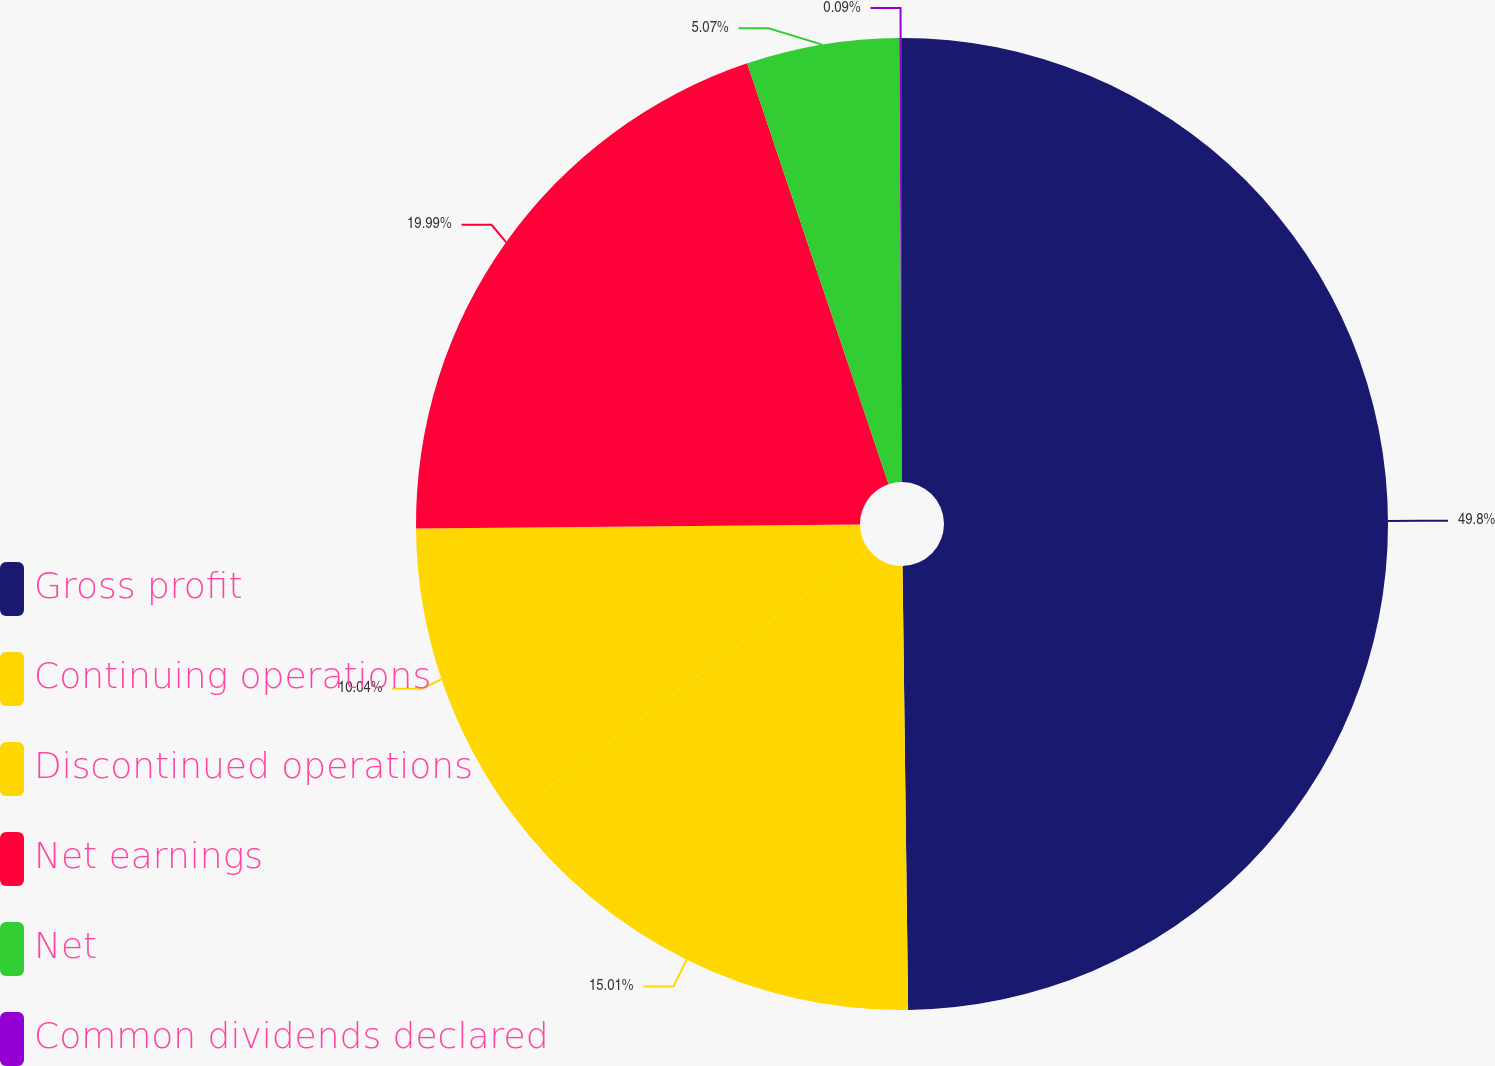<chart> <loc_0><loc_0><loc_500><loc_500><pie_chart><fcel>Gross profit<fcel>Continuing operations<fcel>Discontinued operations<fcel>Net earnings<fcel>Net<fcel>Common dividends declared<nl><fcel>49.8%<fcel>15.01%<fcel>10.04%<fcel>19.99%<fcel>5.07%<fcel>0.09%<nl></chart> 